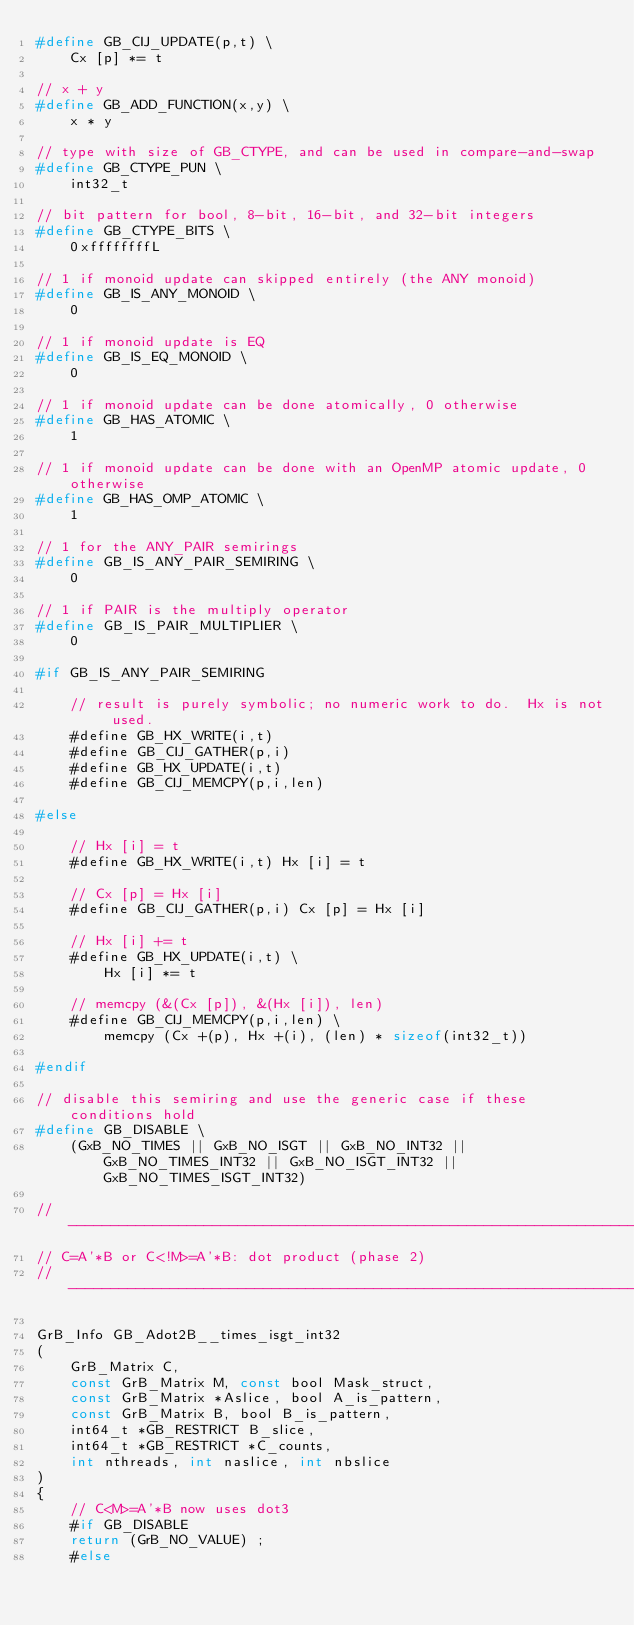Convert code to text. <code><loc_0><loc_0><loc_500><loc_500><_C_>#define GB_CIJ_UPDATE(p,t) \
    Cx [p] *= t

// x + y
#define GB_ADD_FUNCTION(x,y) \
    x * y

// type with size of GB_CTYPE, and can be used in compare-and-swap
#define GB_CTYPE_PUN \
    int32_t

// bit pattern for bool, 8-bit, 16-bit, and 32-bit integers
#define GB_CTYPE_BITS \
    0xffffffffL

// 1 if monoid update can skipped entirely (the ANY monoid)
#define GB_IS_ANY_MONOID \
    0

// 1 if monoid update is EQ
#define GB_IS_EQ_MONOID \
    0

// 1 if monoid update can be done atomically, 0 otherwise
#define GB_HAS_ATOMIC \
    1

// 1 if monoid update can be done with an OpenMP atomic update, 0 otherwise
#define GB_HAS_OMP_ATOMIC \
    1

// 1 for the ANY_PAIR semirings
#define GB_IS_ANY_PAIR_SEMIRING \
    0

// 1 if PAIR is the multiply operator 
#define GB_IS_PAIR_MULTIPLIER \
    0

#if GB_IS_ANY_PAIR_SEMIRING

    // result is purely symbolic; no numeric work to do.  Hx is not used.
    #define GB_HX_WRITE(i,t)
    #define GB_CIJ_GATHER(p,i)
    #define GB_HX_UPDATE(i,t)
    #define GB_CIJ_MEMCPY(p,i,len)

#else

    // Hx [i] = t
    #define GB_HX_WRITE(i,t) Hx [i] = t

    // Cx [p] = Hx [i]
    #define GB_CIJ_GATHER(p,i) Cx [p] = Hx [i]

    // Hx [i] += t
    #define GB_HX_UPDATE(i,t) \
        Hx [i] *= t

    // memcpy (&(Cx [p]), &(Hx [i]), len)
    #define GB_CIJ_MEMCPY(p,i,len) \
        memcpy (Cx +(p), Hx +(i), (len) * sizeof(int32_t))

#endif

// disable this semiring and use the generic case if these conditions hold
#define GB_DISABLE \
    (GxB_NO_TIMES || GxB_NO_ISGT || GxB_NO_INT32 || GxB_NO_TIMES_INT32 || GxB_NO_ISGT_INT32 || GxB_NO_TIMES_ISGT_INT32)

//------------------------------------------------------------------------------
// C=A'*B or C<!M>=A'*B: dot product (phase 2)
//------------------------------------------------------------------------------

GrB_Info GB_Adot2B__times_isgt_int32
(
    GrB_Matrix C,
    const GrB_Matrix M, const bool Mask_struct,
    const GrB_Matrix *Aslice, bool A_is_pattern,
    const GrB_Matrix B, bool B_is_pattern,
    int64_t *GB_RESTRICT B_slice,
    int64_t *GB_RESTRICT *C_counts,
    int nthreads, int naslice, int nbslice
)
{ 
    // C<M>=A'*B now uses dot3
    #if GB_DISABLE
    return (GrB_NO_VALUE) ;
    #else</code> 